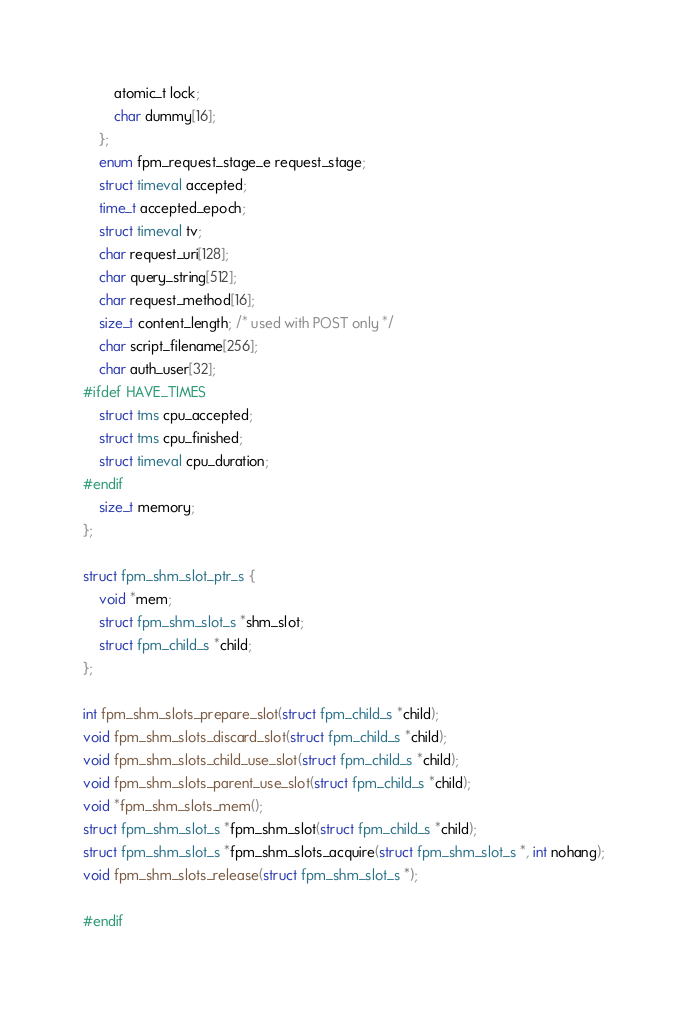<code> <loc_0><loc_0><loc_500><loc_500><_C_>		atomic_t lock;
		char dummy[16];
	};
	enum fpm_request_stage_e request_stage;
	struct timeval accepted;
	time_t accepted_epoch;
	struct timeval tv;
	char request_uri[128];
	char query_string[512];
	char request_method[16];
	size_t content_length; /* used with POST only */
	char script_filename[256];
	char auth_user[32];
#ifdef HAVE_TIMES
	struct tms cpu_accepted;
	struct tms cpu_finished;
	struct timeval cpu_duration;
#endif
	size_t memory;
};

struct fpm_shm_slot_ptr_s {
	void *mem;
	struct fpm_shm_slot_s *shm_slot;
	struct fpm_child_s *child;
};

int fpm_shm_slots_prepare_slot(struct fpm_child_s *child);
void fpm_shm_slots_discard_slot(struct fpm_child_s *child);
void fpm_shm_slots_child_use_slot(struct fpm_child_s *child);
void fpm_shm_slots_parent_use_slot(struct fpm_child_s *child);
void *fpm_shm_slots_mem();
struct fpm_shm_slot_s *fpm_shm_slot(struct fpm_child_s *child);
struct fpm_shm_slot_s *fpm_shm_slots_acquire(struct fpm_shm_slot_s *, int nohang);
void fpm_shm_slots_release(struct fpm_shm_slot_s *);

#endif

</code> 